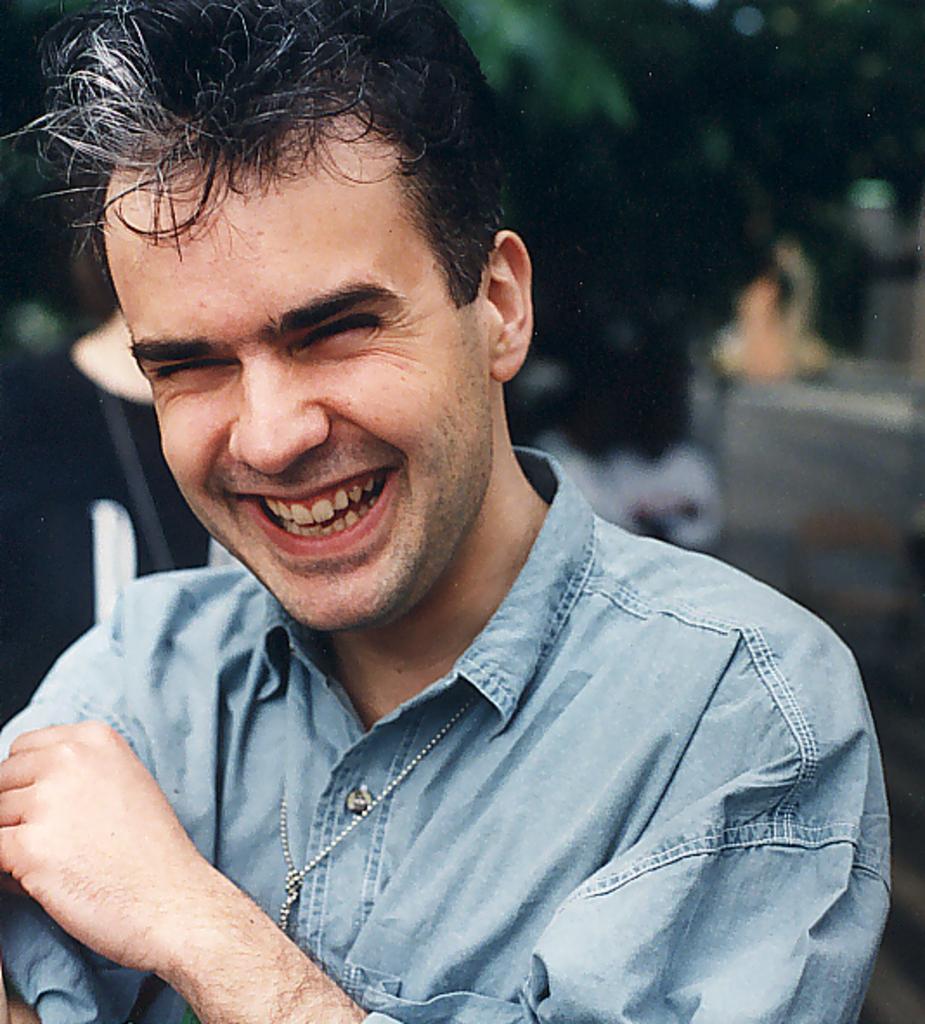Can you describe this image briefly? In this image in front there is a person wearing a smile on his face and the background of the image is blur. 